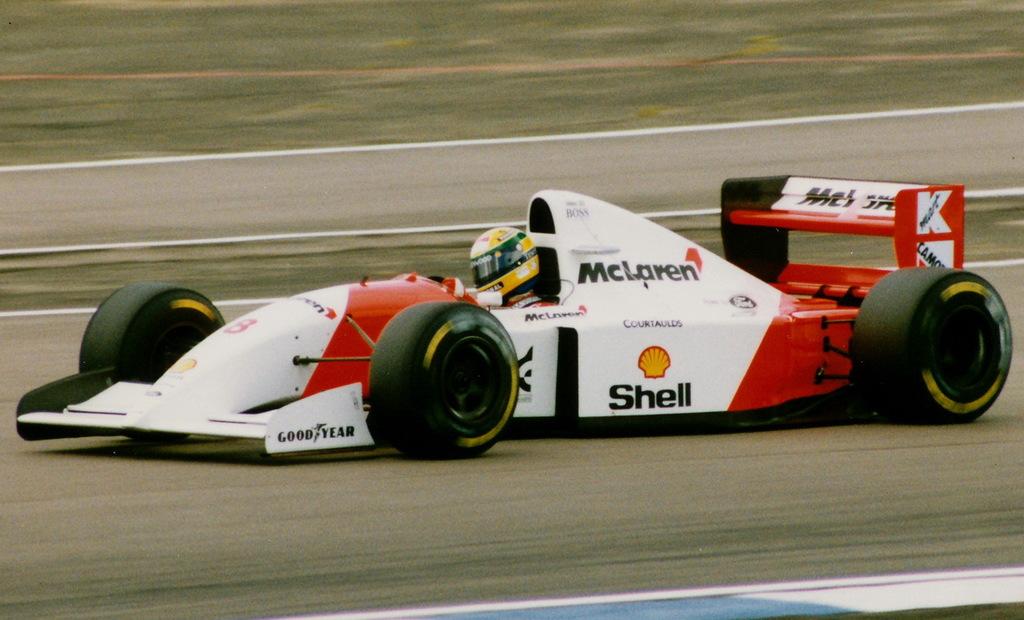What tire brand sponsor is on this racecar?
Offer a very short reply. Goodyear. 